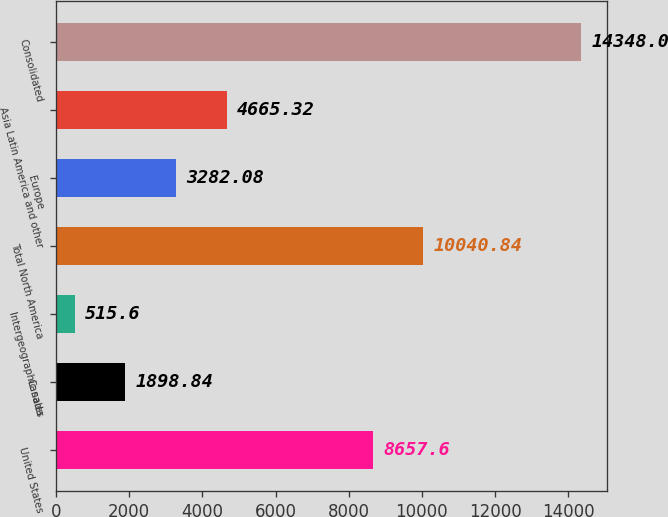Convert chart to OTSL. <chart><loc_0><loc_0><loc_500><loc_500><bar_chart><fcel>United States<fcel>Canada<fcel>Intergeographic sales<fcel>Total North America<fcel>Europe<fcel>Asia Latin America and other<fcel>Consolidated<nl><fcel>8657.6<fcel>1898.84<fcel>515.6<fcel>10040.8<fcel>3282.08<fcel>4665.32<fcel>14348<nl></chart> 